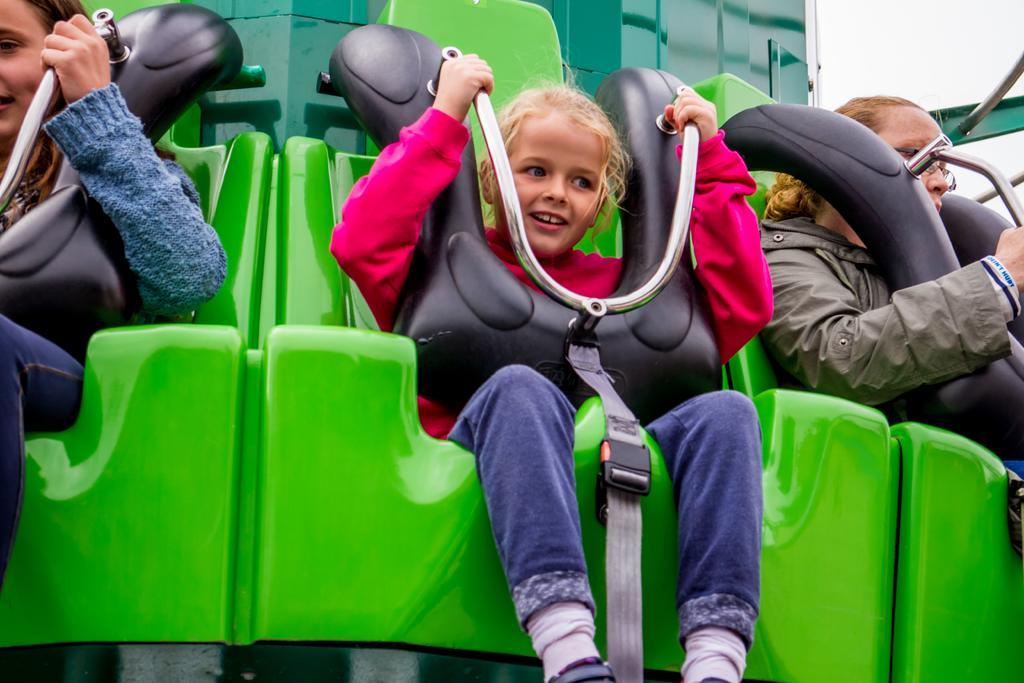Describe this image in one or two sentences. In this image I can see three persons are sitting on a exhibition ride which is green and black in color. I can see the sky in the background. 